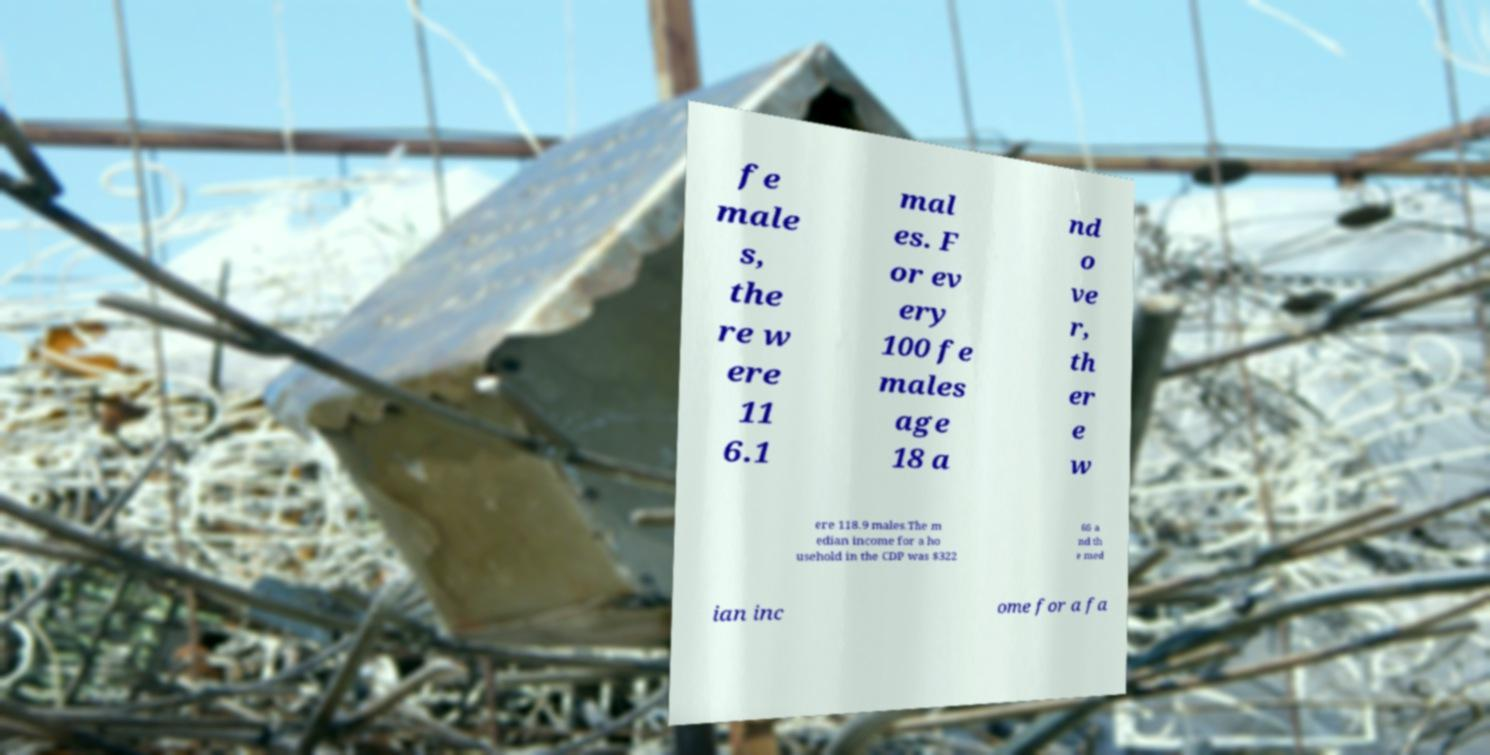For documentation purposes, I need the text within this image transcribed. Could you provide that? fe male s, the re w ere 11 6.1 mal es. F or ev ery 100 fe males age 18 a nd o ve r, th er e w ere 118.9 males.The m edian income for a ho usehold in the CDP was $322 66 a nd th e med ian inc ome for a fa 